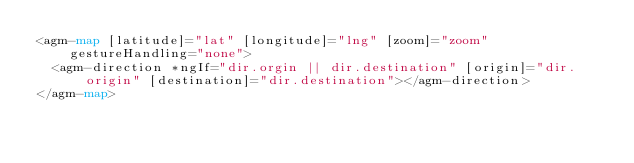Convert code to text. <code><loc_0><loc_0><loc_500><loc_500><_HTML_><agm-map [latitude]="lat" [longitude]="lng" [zoom]="zoom" gestureHandling="none">
  <agm-direction *ngIf="dir.orgin || dir.destination" [origin]="dir.origin" [destination]="dir.destination"></agm-direction>
</agm-map>
</code> 